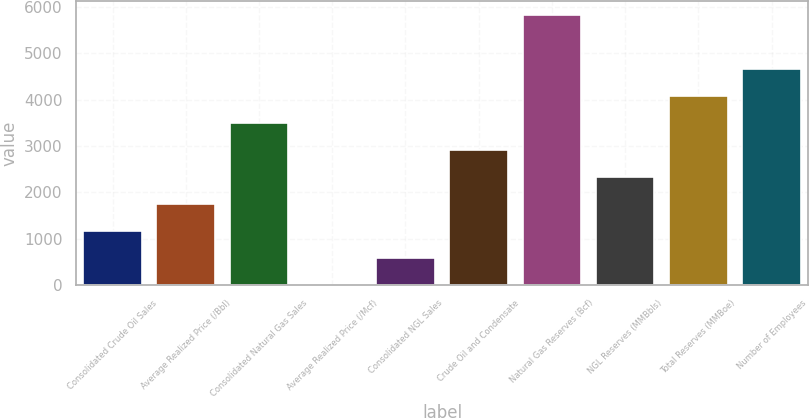Convert chart. <chart><loc_0><loc_0><loc_500><loc_500><bar_chart><fcel>Consolidated Crude Oil Sales<fcel>Average Realized Price (/Bbl)<fcel>Consolidated Natural Gas Sales<fcel>Average Realized Price (/Mcf)<fcel>Consolidated NGL Sales<fcel>Crude Oil and Condensate<fcel>Natural Gas Reserves (Bcf)<fcel>NGL Reserves (MMBbls)<fcel>Total Reserves (MMBoe)<fcel>Number of Employees<nl><fcel>1167.97<fcel>1750.47<fcel>3497.97<fcel>2.97<fcel>585.47<fcel>2915.47<fcel>5828<fcel>2332.97<fcel>4080.47<fcel>4662.97<nl></chart> 